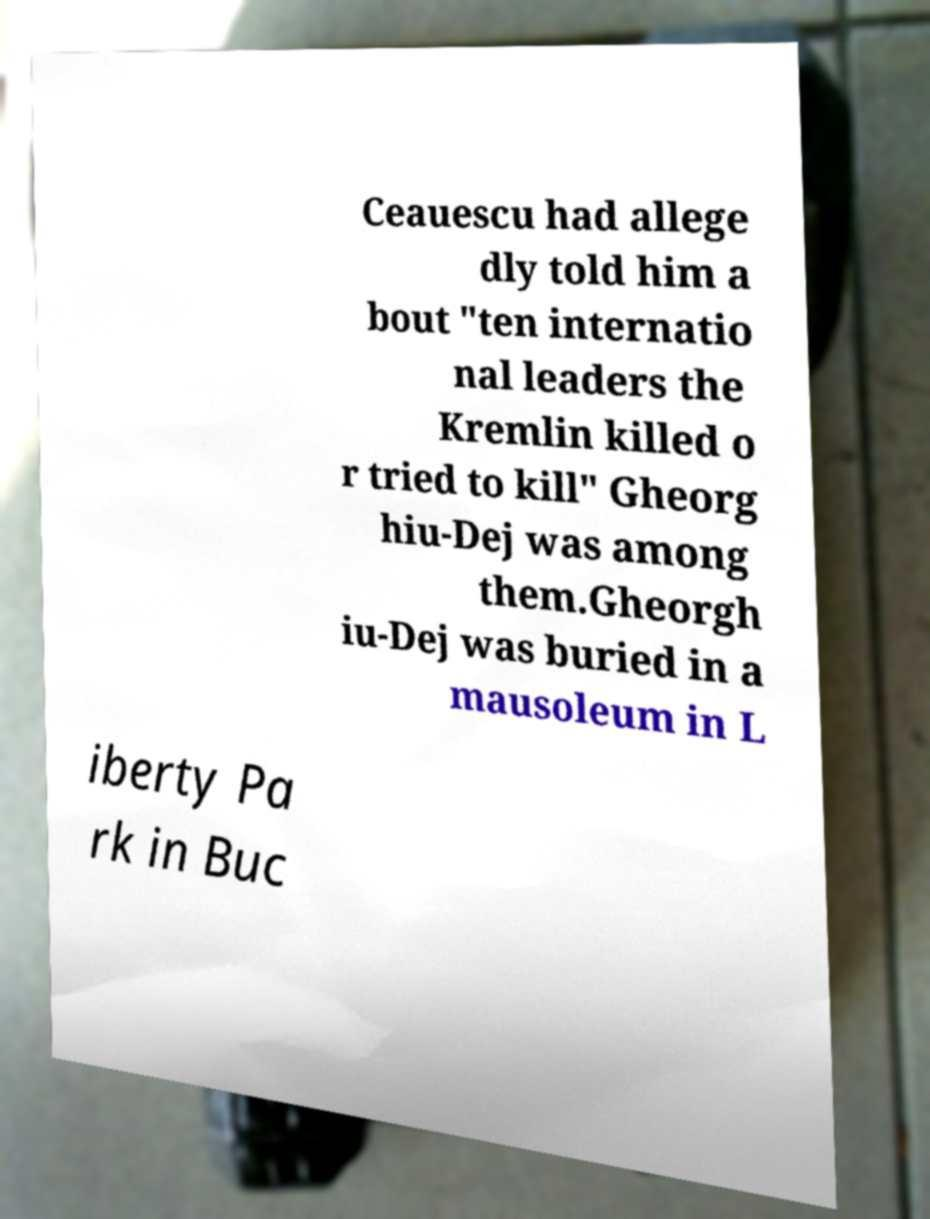Could you extract and type out the text from this image? Ceauescu had allege dly told him a bout "ten internatio nal leaders the Kremlin killed o r tried to kill" Gheorg hiu-Dej was among them.Gheorgh iu-Dej was buried in a mausoleum in L iberty Pa rk in Buc 